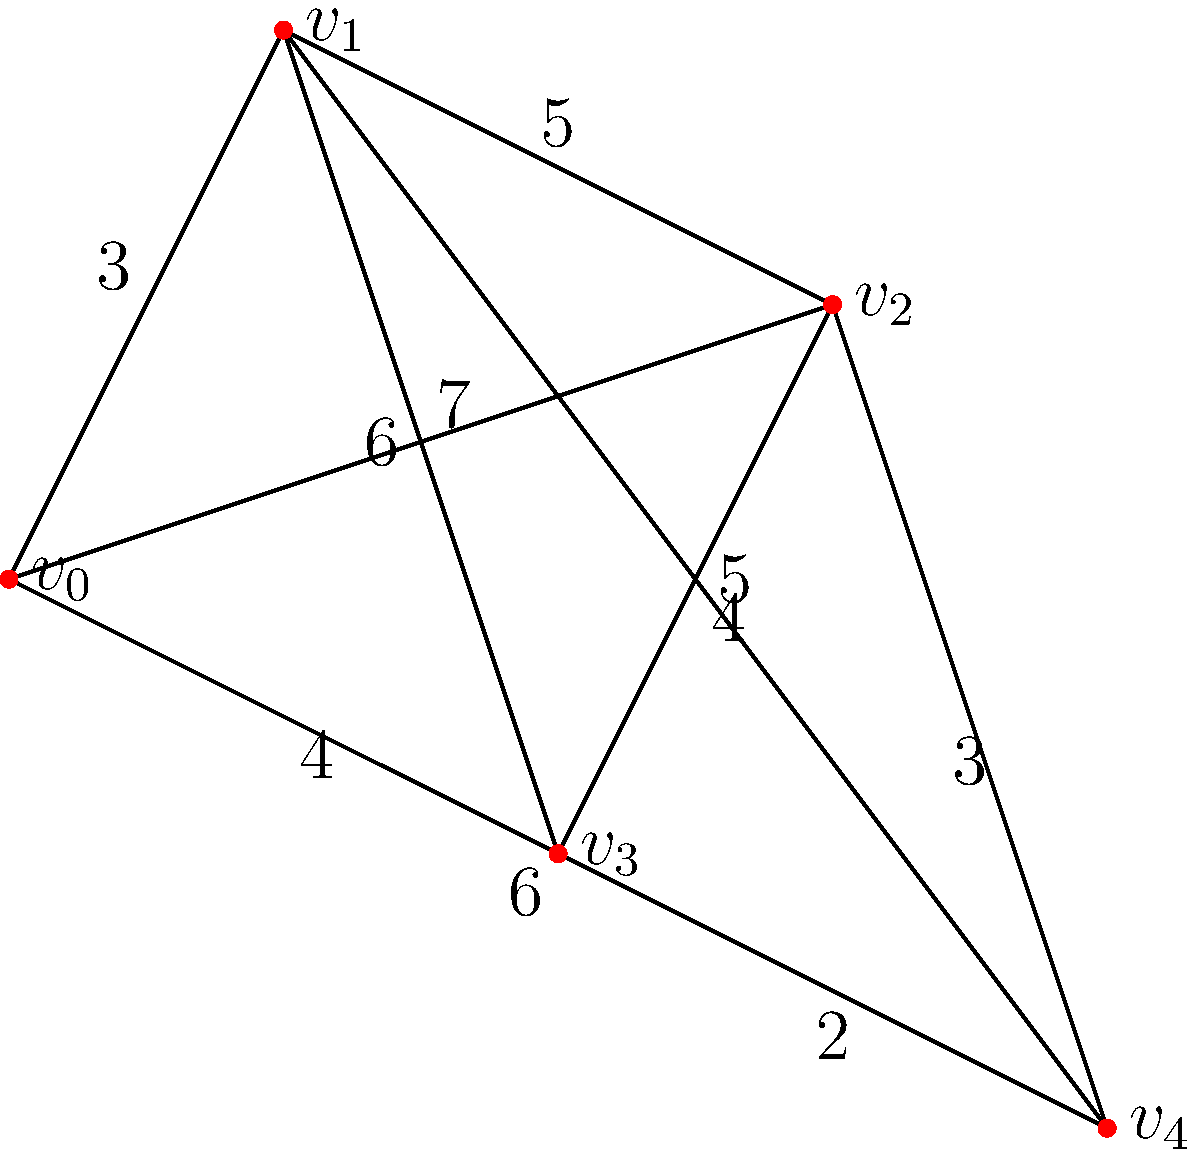As a café owner looking to optimize your delivery service, you need to determine the most efficient route for your delivery person. The graph represents different locations in your neighborhood, with vertices representing addresses and edge weights representing travel times in minutes. What is the minimum time required to visit all locations, starting and ending at your café (vertex $v_0$)? To find the minimum time to visit all locations, we need to solve the Traveling Salesman Problem (TSP) for this graph. Here's a step-by-step approach:

1) First, identify all possible Hamiltonian cycles (paths that visit each vertex exactly once and return to the starting point).

2) Calculate the total weight (time) for each cycle:

   Cycle 1: $v_0 \to v_1 \to v_2 \to v_3 \to v_4 \to v_0$
   Time: $3 + 5 + 4 + 2 + 6 = 20$ minutes

   Cycle 2: $v_0 \to v_1 \to v_2 \to v_4 \to v_3 \to v_0$
   Time: $3 + 5 + 3 + 2 + 4 = 17$ minutes

   Cycle 3: $v_0 \to v_1 \to v_4 \to v_2 \to v_3 \to v_0$
   Time: $3 + 5 + 3 + 4 + 4 = 19$ minutes

   Cycle 4: $v_0 \to v_1 \to v_4 \to v_3 \to v_2 \to v_0$
   Time: $3 + 5 + 2 + 4 + 7 = 21$ minutes

   Cycle 5: $v_0 \to v_2 \to v_1 \to v_3 \to v_4 \to v_0$
   Time: $7 + 5 + 6 + 2 + 6 = 26$ minutes

   Cycle 6: $v_0 \to v_2 \to v_1 \to v_4 \to v_3 \to v_0$
   Time: $7 + 5 + 5 + 2 + 4 = 23$ minutes

   Cycle 7: $v_0 \to v_2 \to v_4 \to v_1 \to v_3 \to v_0$
   Time: $7 + 3 + 5 + 6 + 4 = 25$ minutes

   Cycle 8: $v_0 \to v_3 \to v_1 \to v_2 \to v_4 \to v_0$
   Time: $4 + 6 + 5 + 3 + 6 = 24$ minutes

   Cycle 9: $v_0 \to v_3 \to v_2 \to v_1 \to v_4 \to v_0$
   Time: $4 + 4 + 5 + 5 + 6 = 24$ minutes

   Cycle 10: $v_0 \to v_3 \to v_4 \to v_1 \to v_2 \to v_0$
   Time: $4 + 2 + 5 + 5 + 7 = 23$ minutes

3) The minimum time is the smallest total weight among all cycles, which is 17 minutes (Cycle 2).
Answer: 17 minutes 